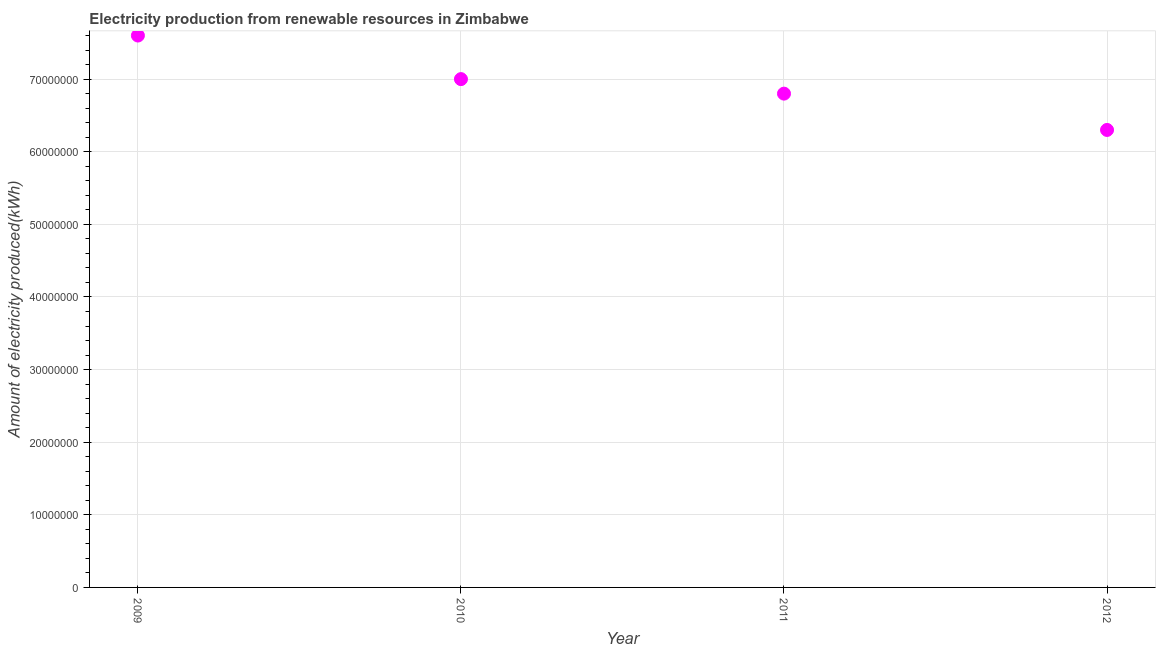What is the amount of electricity produced in 2010?
Your response must be concise. 7.00e+07. Across all years, what is the maximum amount of electricity produced?
Your answer should be compact. 7.60e+07. Across all years, what is the minimum amount of electricity produced?
Your answer should be compact. 6.30e+07. What is the sum of the amount of electricity produced?
Provide a short and direct response. 2.77e+08. What is the difference between the amount of electricity produced in 2009 and 2010?
Make the answer very short. 6.00e+06. What is the average amount of electricity produced per year?
Provide a succinct answer. 6.92e+07. What is the median amount of electricity produced?
Your answer should be compact. 6.90e+07. What is the ratio of the amount of electricity produced in 2009 to that in 2012?
Provide a succinct answer. 1.21. Is the amount of electricity produced in 2011 less than that in 2012?
Give a very brief answer. No. What is the difference between the highest and the lowest amount of electricity produced?
Keep it short and to the point. 1.30e+07. What is the difference between two consecutive major ticks on the Y-axis?
Provide a succinct answer. 1.00e+07. Are the values on the major ticks of Y-axis written in scientific E-notation?
Make the answer very short. No. Does the graph contain any zero values?
Give a very brief answer. No. Does the graph contain grids?
Your answer should be very brief. Yes. What is the title of the graph?
Your answer should be compact. Electricity production from renewable resources in Zimbabwe. What is the label or title of the Y-axis?
Your answer should be compact. Amount of electricity produced(kWh). What is the Amount of electricity produced(kWh) in 2009?
Your response must be concise. 7.60e+07. What is the Amount of electricity produced(kWh) in 2010?
Give a very brief answer. 7.00e+07. What is the Amount of electricity produced(kWh) in 2011?
Provide a short and direct response. 6.80e+07. What is the Amount of electricity produced(kWh) in 2012?
Your answer should be very brief. 6.30e+07. What is the difference between the Amount of electricity produced(kWh) in 2009 and 2010?
Give a very brief answer. 6.00e+06. What is the difference between the Amount of electricity produced(kWh) in 2009 and 2012?
Your answer should be compact. 1.30e+07. What is the difference between the Amount of electricity produced(kWh) in 2010 and 2011?
Keep it short and to the point. 2.00e+06. What is the ratio of the Amount of electricity produced(kWh) in 2009 to that in 2010?
Provide a short and direct response. 1.09. What is the ratio of the Amount of electricity produced(kWh) in 2009 to that in 2011?
Offer a very short reply. 1.12. What is the ratio of the Amount of electricity produced(kWh) in 2009 to that in 2012?
Your answer should be very brief. 1.21. What is the ratio of the Amount of electricity produced(kWh) in 2010 to that in 2011?
Make the answer very short. 1.03. What is the ratio of the Amount of electricity produced(kWh) in 2010 to that in 2012?
Your answer should be compact. 1.11. What is the ratio of the Amount of electricity produced(kWh) in 2011 to that in 2012?
Provide a short and direct response. 1.08. 